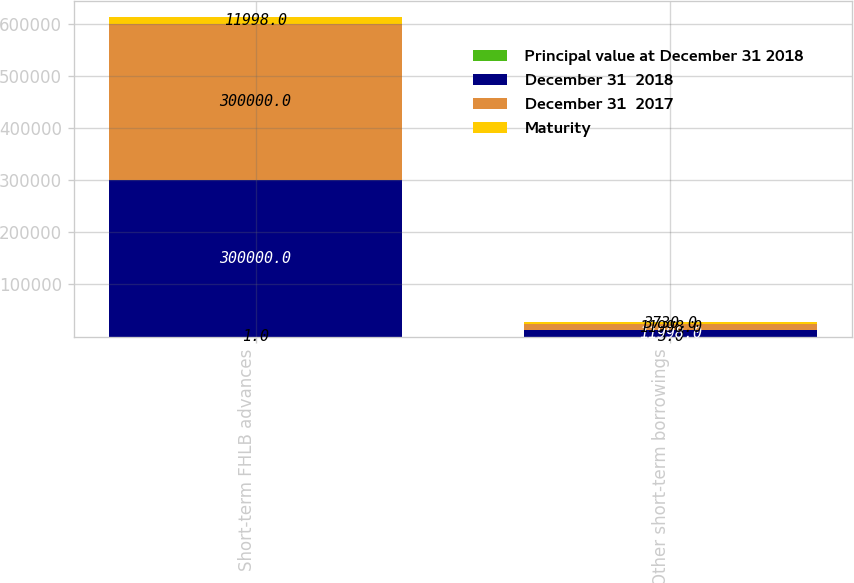Convert chart to OTSL. <chart><loc_0><loc_0><loc_500><loc_500><stacked_bar_chart><ecel><fcel>Short-term FHLB advances<fcel>Other short-term borrowings<nl><fcel>Principal value at December 31 2018<fcel>1<fcel>3<nl><fcel>December 31  2018<fcel>300000<fcel>11998<nl><fcel>December 31  2017<fcel>300000<fcel>11998<nl><fcel>Maturity<fcel>11998<fcel>3730<nl></chart> 